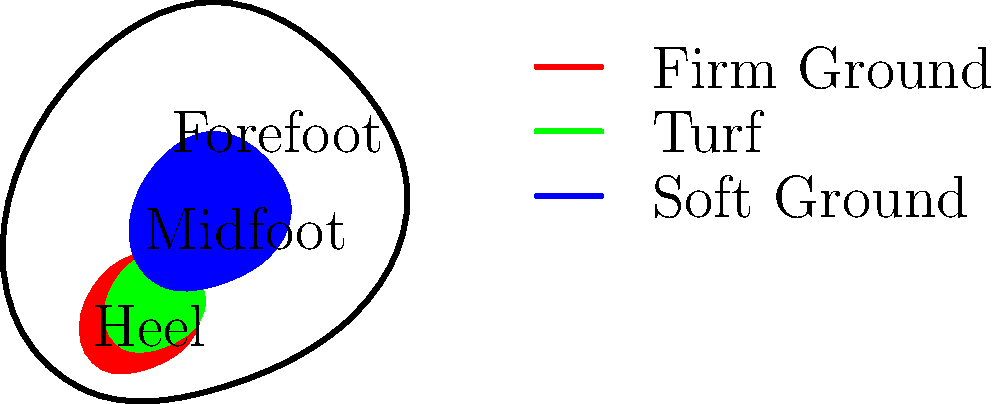Based on the foot pressure map shown, which type of soccer cleat is likely to provide the best traction and stability for a goalkeeper playing on a wet, muddy field? To determine the best type of cleat for a goalkeeper on a wet, muddy field, we need to consider the pressure distribution and the playing conditions:

1. Analyze the pressure map:
   - Red (heel): High pressure, associated with firm ground cleats
   - Green (midfoot): Moderate pressure, associated with turf cleats
   - Blue (forefoot): High pressure, associated with soft ground cleats

2. Consider the playing conditions:
   - Wet, muddy field suggests soft ground conditions

3. Evaluate cleat types:
   - Firm ground cleats (red) are designed for firm natural surfaces and may not provide enough traction in mud
   - Turf cleats (green) are designed for artificial surfaces and would not be suitable for muddy conditions
   - Soft ground cleats (blue) are specifically designed for wet and muddy conditions

4. Assess goalkeeper needs:
   - Goalkeepers require excellent traction and stability for quick movements and sudden changes in direction

5. Match cleat type to conditions and needs:
   - Soft ground cleats (blue) provide the best traction in muddy conditions due to their longer, removable studs

Therefore, the soft ground cleats, represented by the blue forefoot area in the pressure map, would likely provide the best traction and stability for a goalkeeper on a wet, muddy field.
Answer: Soft ground cleats 